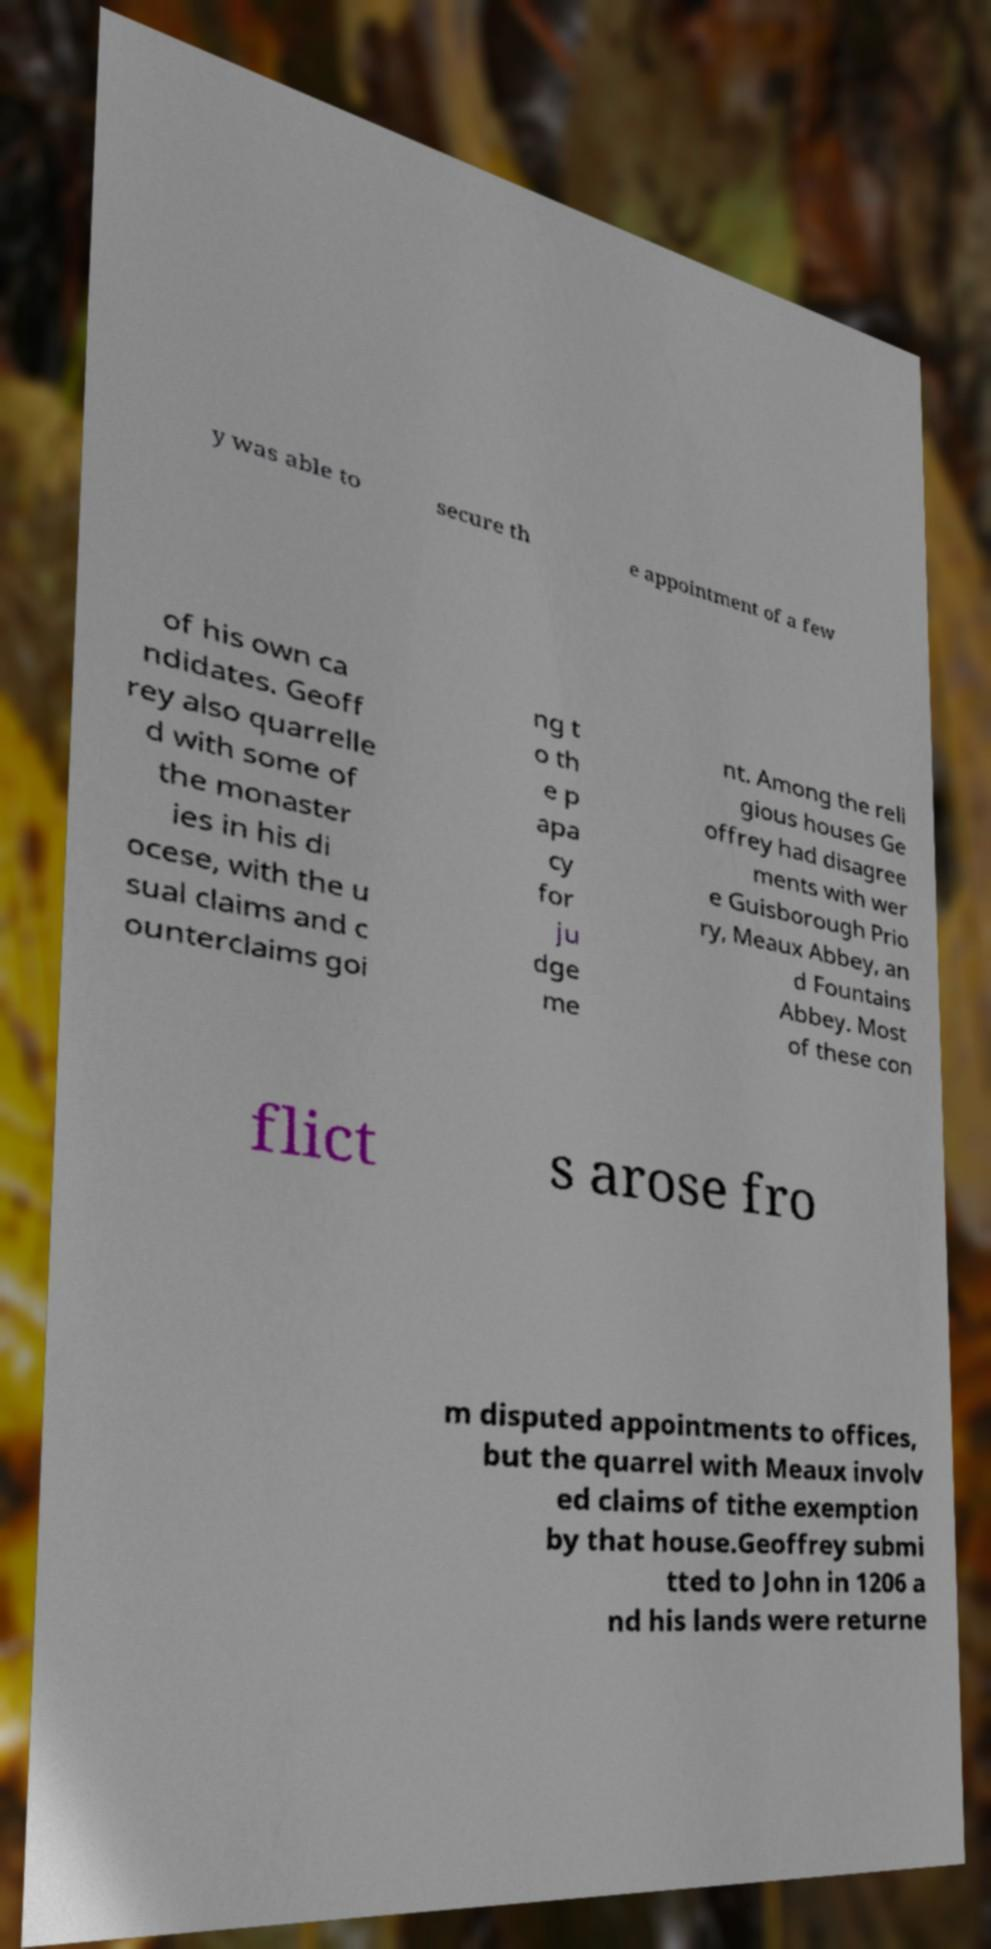Could you extract and type out the text from this image? y was able to secure th e appointment of a few of his own ca ndidates. Geoff rey also quarrelle d with some of the monaster ies in his di ocese, with the u sual claims and c ounterclaims goi ng t o th e p apa cy for ju dge me nt. Among the reli gious houses Ge offrey had disagree ments with wer e Guisborough Prio ry, Meaux Abbey, an d Fountains Abbey. Most of these con flict s arose fro m disputed appointments to offices, but the quarrel with Meaux involv ed claims of tithe exemption by that house.Geoffrey submi tted to John in 1206 a nd his lands were returne 